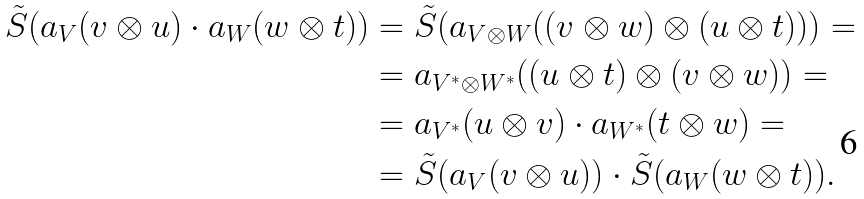<formula> <loc_0><loc_0><loc_500><loc_500>\tilde { S } ( a _ { V } ( v \otimes u ) \cdot a _ { W } ( w \otimes t ) ) & = \tilde { S } ( a _ { V \otimes W } ( ( v \otimes w ) \otimes ( u \otimes t ) ) ) = \\ & = a _ { V ^ { * } \otimes W ^ { * } } ( ( u \otimes t ) \otimes ( v \otimes w ) ) = \\ & = a _ { V ^ { * } } ( u \otimes v ) \cdot a _ { W ^ { * } } ( t \otimes w ) = \\ & = \tilde { S } ( a _ { V } ( v \otimes u ) ) \cdot \tilde { S } ( a _ { W } ( w \otimes t ) ) .</formula> 